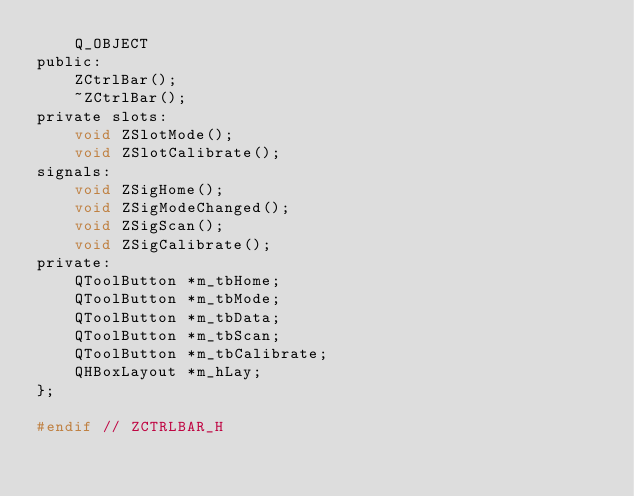<code> <loc_0><loc_0><loc_500><loc_500><_C_>    Q_OBJECT
public:
    ZCtrlBar();
    ~ZCtrlBar();
private slots:
    void ZSlotMode();
    void ZSlotCalibrate();
signals:
    void ZSigHome();
    void ZSigModeChanged();
    void ZSigScan();
    void ZSigCalibrate();
private:
    QToolButton *m_tbHome;
    QToolButton *m_tbMode;
    QToolButton *m_tbData;
    QToolButton *m_tbScan;
    QToolButton *m_tbCalibrate;
    QHBoxLayout *m_hLay;
};

#endif // ZCTRLBAR_H
</code> 